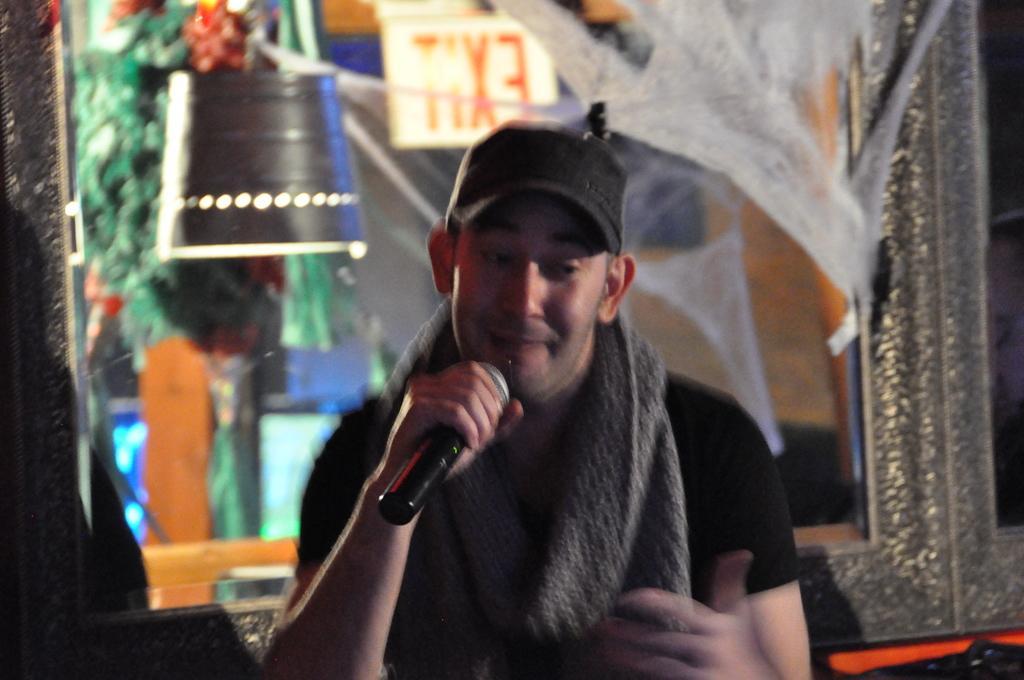Describe this image in one or two sentences. In the photo there is a man who is wearing stole around his neck and sitting he is holding mike in his right hand in the background there is a light, exit door and a glass and also trees. 